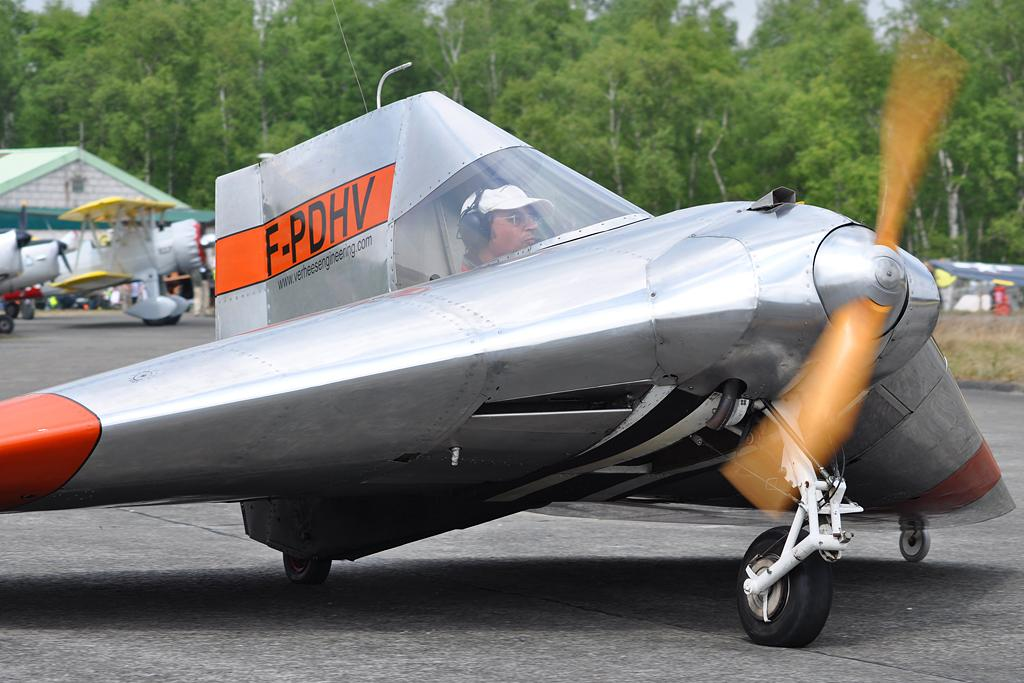What is the man in the image doing? The man is sitting in an airplane. Where is the airplane located in the image? The airplane is on the road. What can be seen in the background of the image? There are trees, airplanes, and a building in the background of the image. What type of ice can be seen on the stage in the image? There is no stage or ice present in the image. 